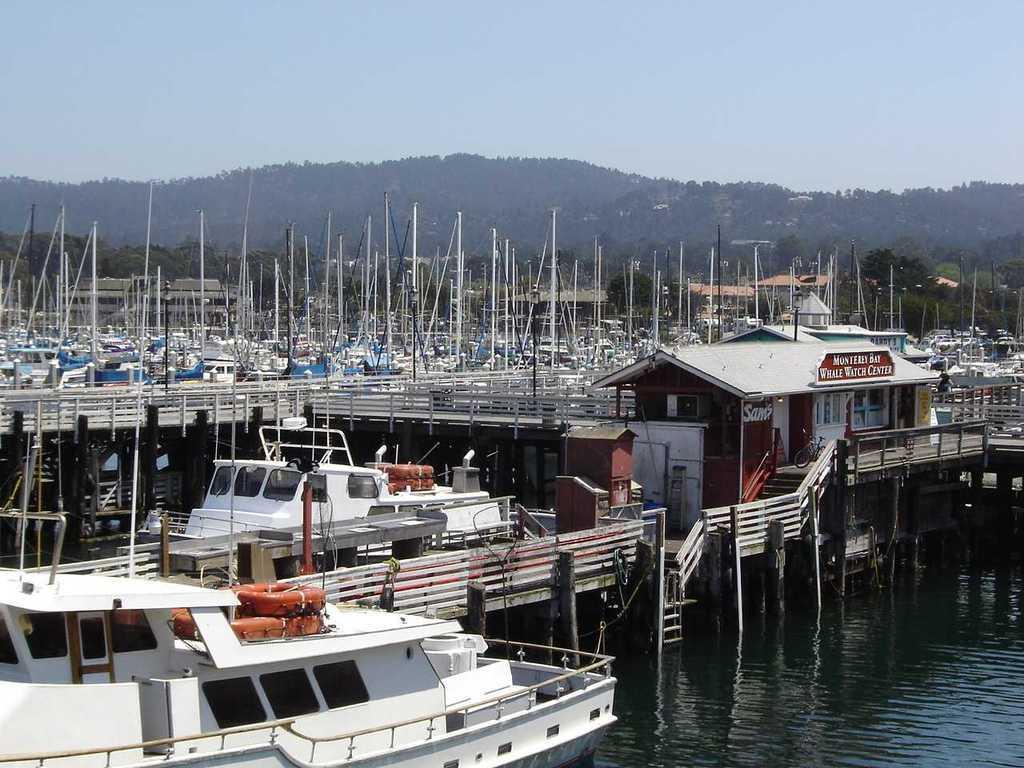How would you summarize this image in a sentence or two? This image consists of many boats and ships. It looks like a port. In the background, there are mountains covered with trees and plants. At the top, there is sky. At the bottom, there is water. 